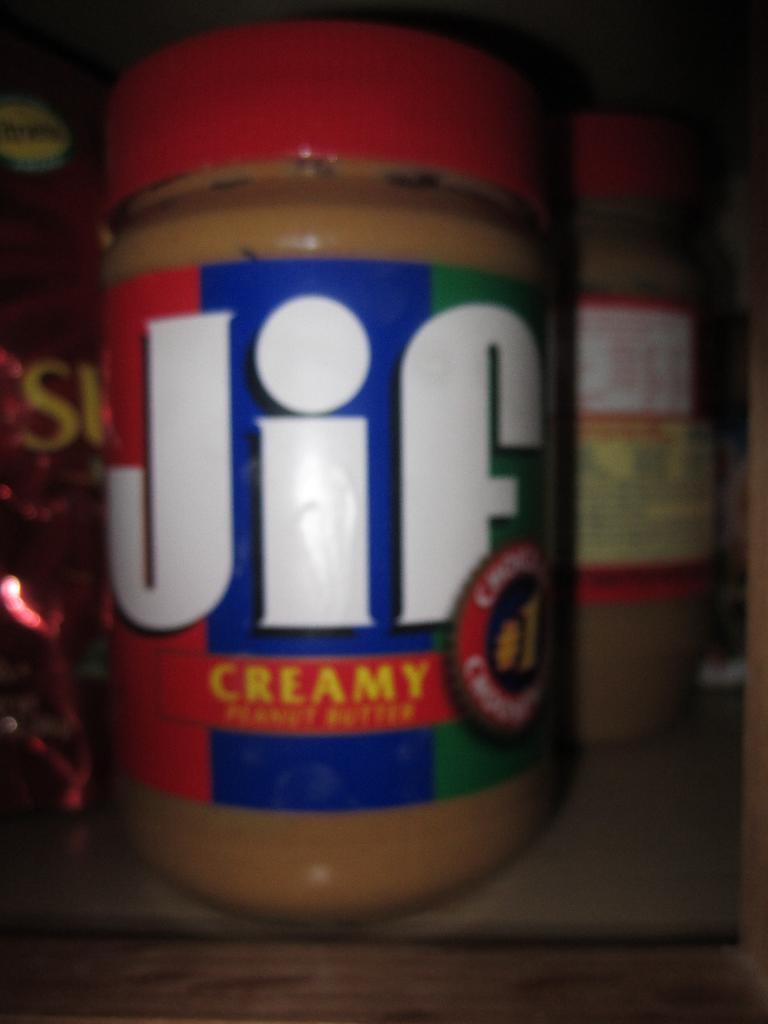Could you give a brief overview of what you see in this image? In the image there is a bottle in which it is labelled as jif which is placed on table. 